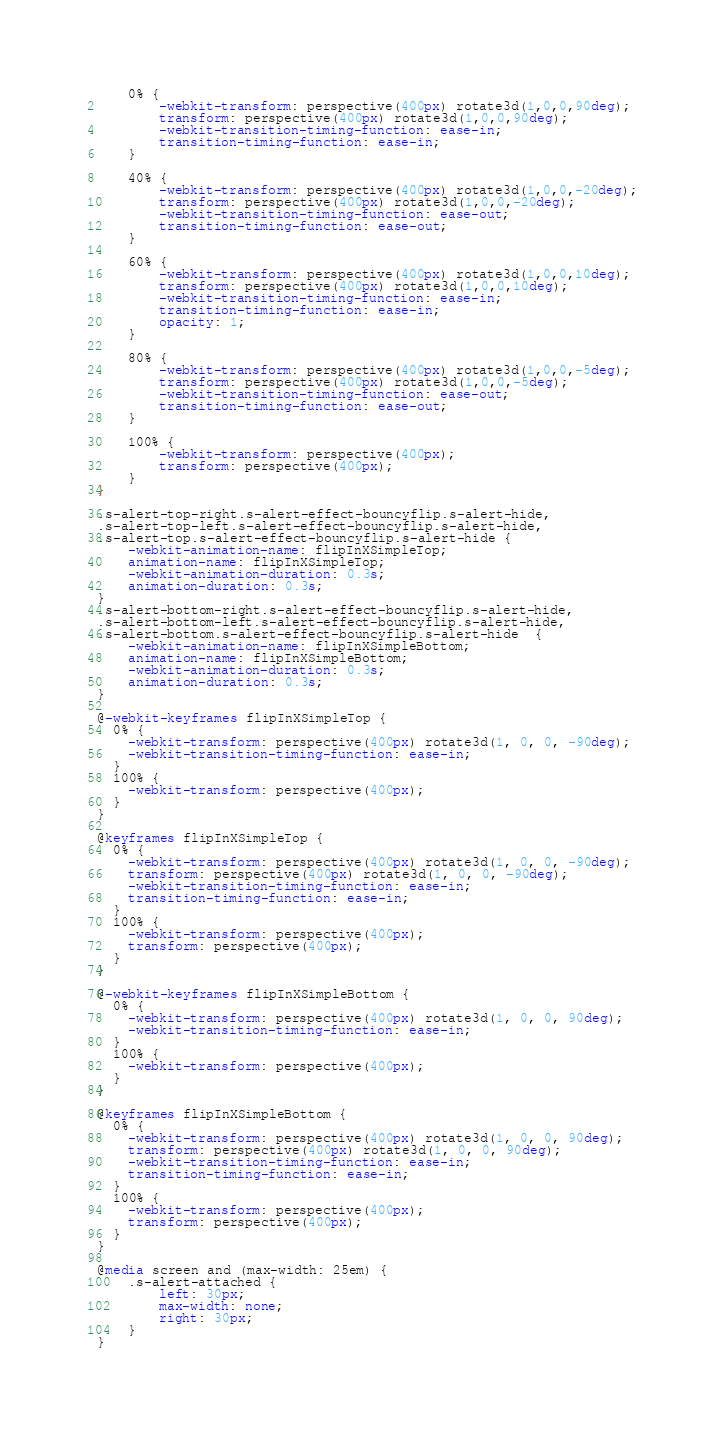Convert code to text. <code><loc_0><loc_0><loc_500><loc_500><_CSS_>    0% {
        -webkit-transform: perspective(400px) rotate3d(1,0,0,90deg);
        transform: perspective(400px) rotate3d(1,0,0,90deg);
        -webkit-transition-timing-function: ease-in;
        transition-timing-function: ease-in;
    }

    40% {
        -webkit-transform: perspective(400px) rotate3d(1,0,0,-20deg);
        transform: perspective(400px) rotate3d(1,0,0,-20deg);
        -webkit-transition-timing-function: ease-out;
        transition-timing-function: ease-out;
    }

    60% {
        -webkit-transform: perspective(400px) rotate3d(1,0,0,10deg);
        transform: perspective(400px) rotate3d(1,0,0,10deg);
        -webkit-transition-timing-function: ease-in;
        transition-timing-function: ease-in;
        opacity: 1;
    }

    80% {
        -webkit-transform: perspective(400px) rotate3d(1,0,0,-5deg);
        transform: perspective(400px) rotate3d(1,0,0,-5deg);
        -webkit-transition-timing-function: ease-out;
        transition-timing-function: ease-out;
    }

    100% {
        -webkit-transform: perspective(400px);
        transform: perspective(400px);
    }
}

.s-alert-top-right.s-alert-effect-bouncyflip.s-alert-hide,
.s-alert-top-left.s-alert-effect-bouncyflip.s-alert-hide,
.s-alert-top.s-alert-effect-bouncyflip.s-alert-hide {
    -webkit-animation-name: flipInXSimpleTop;
    animation-name: flipInXSimpleTop;
    -webkit-animation-duration: 0.3s;
    animation-duration: 0.3s;
}
.s-alert-bottom-right.s-alert-effect-bouncyflip.s-alert-hide,
.s-alert-bottom-left.s-alert-effect-bouncyflip.s-alert-hide,
.s-alert-bottom.s-alert-effect-bouncyflip.s-alert-hide  {
    -webkit-animation-name: flipInXSimpleBottom;
    animation-name: flipInXSimpleBottom;
    -webkit-animation-duration: 0.3s;
    animation-duration: 0.3s;
}

@-webkit-keyframes flipInXSimpleTop {
  0% {
    -webkit-transform: perspective(400px) rotate3d(1, 0, 0, -90deg);
    -webkit-transition-timing-function: ease-in;
  }
  100% {
    -webkit-transform: perspective(400px);
  }
}

@keyframes flipInXSimpleTop {
  0% {
    -webkit-transform: perspective(400px) rotate3d(1, 0, 0, -90deg);
    transform: perspective(400px) rotate3d(1, 0, 0, -90deg);
    -webkit-transition-timing-function: ease-in;
    transition-timing-function: ease-in;
  }
  100% {
    -webkit-transform: perspective(400px);
    transform: perspective(400px);
  }
}

@-webkit-keyframes flipInXSimpleBottom {
  0% {
    -webkit-transform: perspective(400px) rotate3d(1, 0, 0, 90deg);
    -webkit-transition-timing-function: ease-in;
  }
  100% {
    -webkit-transform: perspective(400px);
  }
}

@keyframes flipInXSimpleBottom {
  0% {
    -webkit-transform: perspective(400px) rotate3d(1, 0, 0, 90deg);
    transform: perspective(400px) rotate3d(1, 0, 0, 90deg);
    -webkit-transition-timing-function: ease-in;
    transition-timing-function: ease-in;
  }
  100% {
    -webkit-transform: perspective(400px);
    transform: perspective(400px);
  }
}

@media screen and (max-width: 25em) {
    .s-alert-attached {
        left: 30px;
        max-width: none;
        right: 30px;
    }
}</code> 